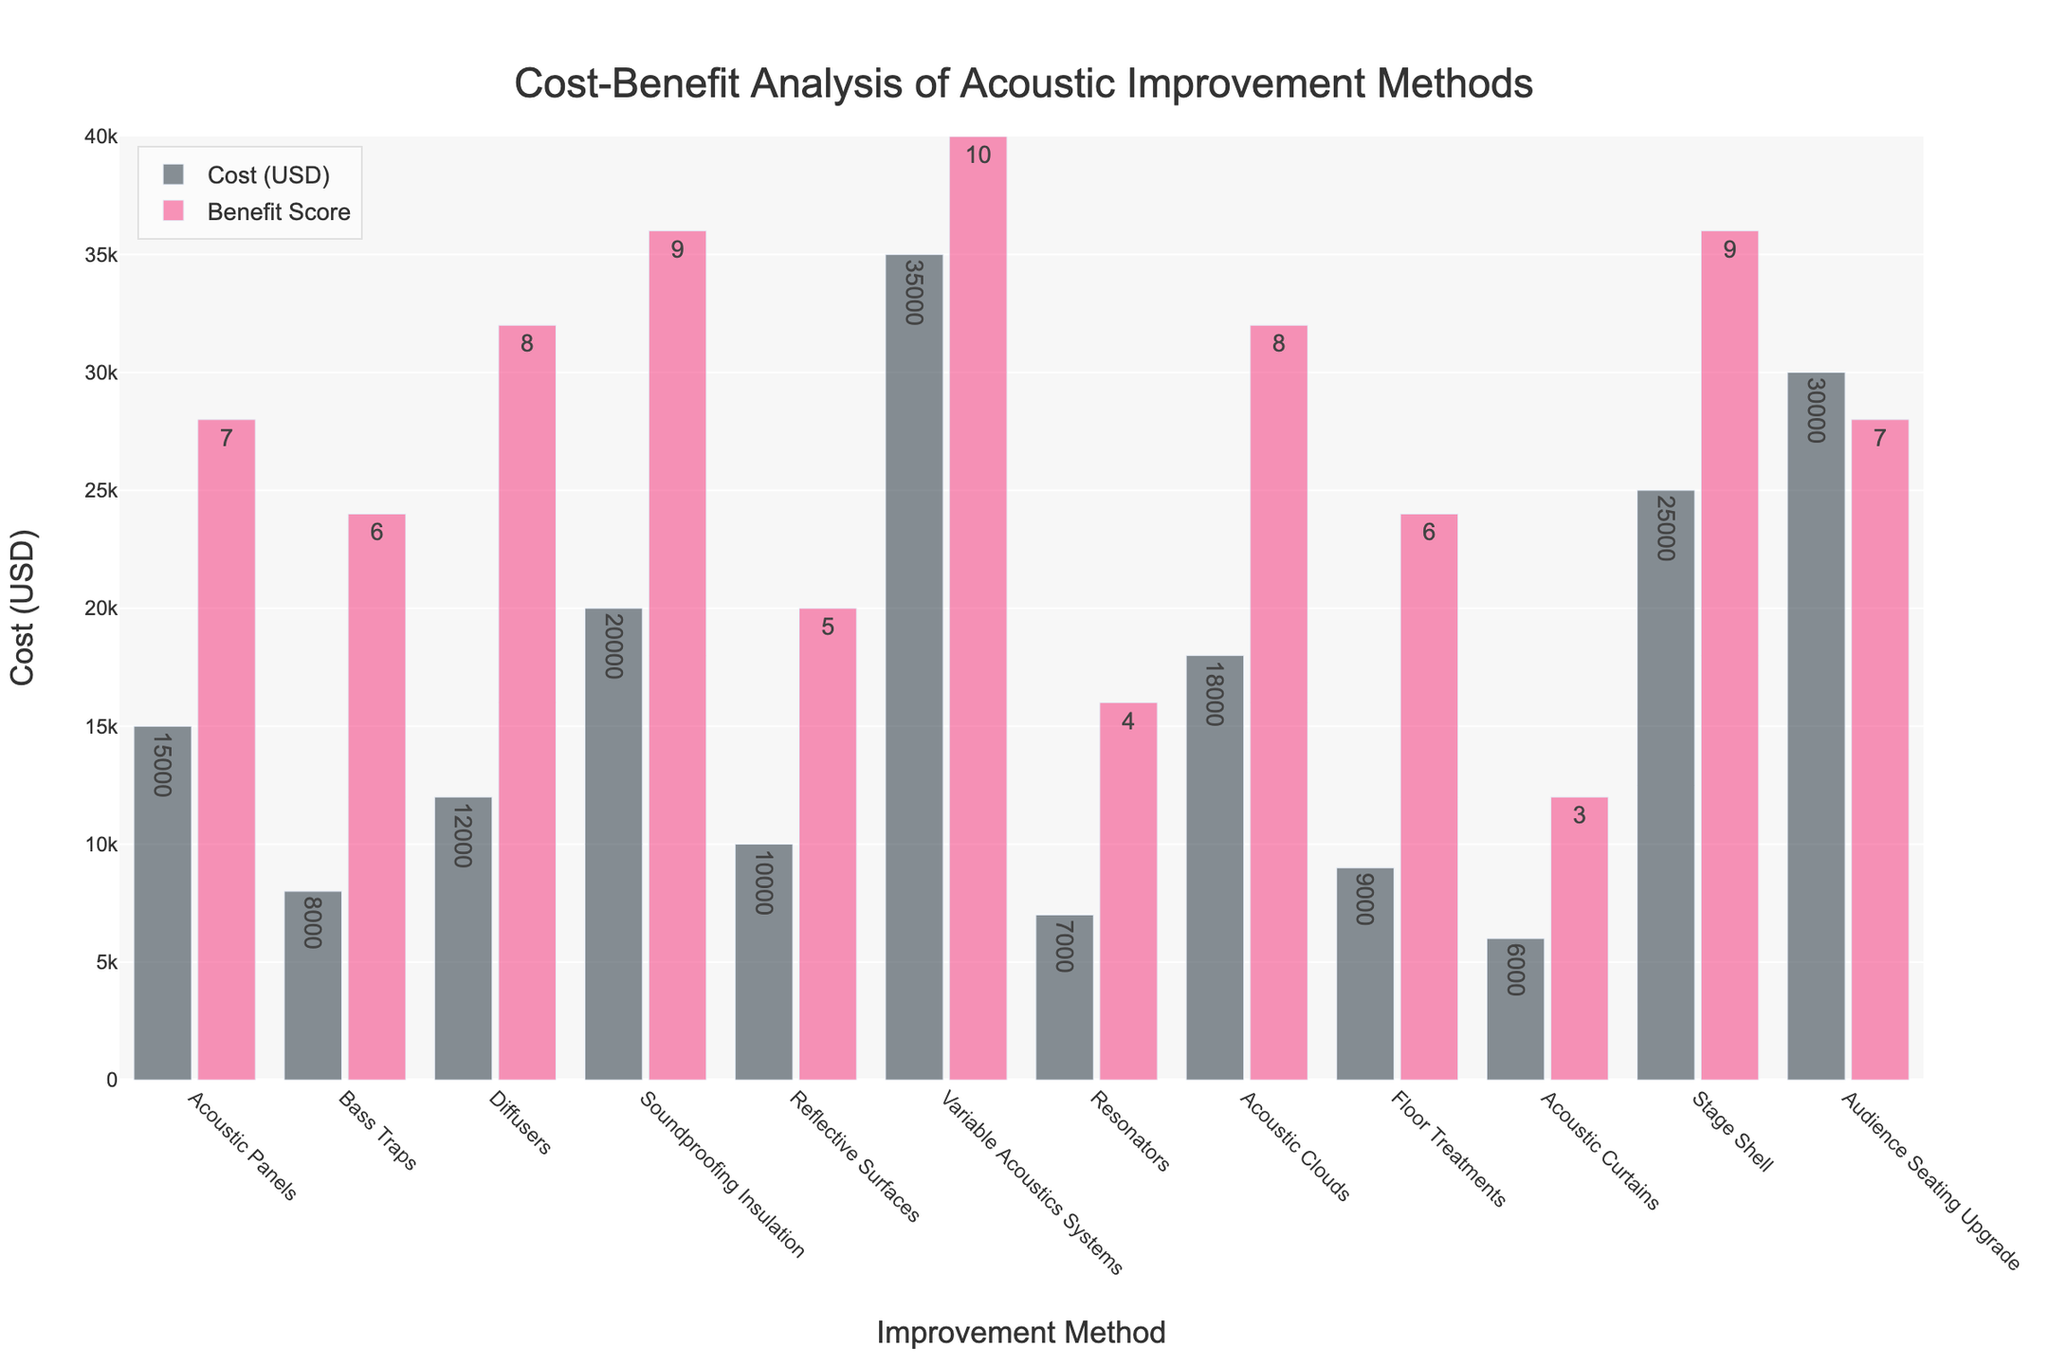Which improvement method has the highest benefit score? By looking at the height of the pink bars in the figure, the highest benefit score is 10, which corresponds to the Variable Acoustics Systems method.
Answer: Variable Acoustics Systems Which method has the lowest cost? By comparing the height of the brown bars in the figure, the lowest cost is 6000 USD, which corresponds to the Acoustic Curtains method.
Answer: Acoustic Curtains What is the total cost for Acoustic Panels, Bass Traps, and Diffusers combined? Add the costs for each method: Acoustic Panels (15000 USD) + Bass Traps (8000 USD) + Diffusers (12000 USD). 15000 + 8000 + 12000 = 35000 USD.
Answer: 35000 USD Which method provides a better cost-benefit ratio: Acoustic Panels or Floor Treatments? Calculate the cost-benefit ratio for both methods by dividing the cost by the benefit score and comparing them. Acoustic Panels: 15000/7 ≈ 2143 USD per benefit point. Floor Treatments: 9000/6 = 1500 USD per benefit point. Floor Treatments has a better ratio.
Answer: Floor Treatments Which method has a benefit score less than 5 and what is its cost? Look at the pink bars with a height corresponding to benefit scores less than 5. Resonators and Acoustic Curtains have benefit scores of 4 and 3, respectively. The costs are 7000 USD and 6000 USD.
Answer: Resonators and Acoustic Curtains, cost: 7000 USD and 6000 USD respectively What is the difference in cost between the most expensive and the least expensive methods? The most expensive method is Variable Acoustics Systems (35000 USD), and the least expensive method is Acoustic Curtains (6000 USD). Subtract the cost of Acoustic Curtains from Variable Acoustics Systems: 35000 - 6000 = 29000 USD.
Answer: 29000 USD Which improvement methods have a benefit score of 8? Identify the pink bars with a height corresponding to a benefit score of 8. The methods are Diffusers and Acoustic Clouds.
Answer: Diffusers and Acoustic Clouds What is the average cost of all improvement methods? Sum all the costs and divide by the number of methods. Total cost is 15000 + 8000 + 12000 + 20000 + 10000 + 35000 + 7000 + 18000 + 9000 + 6000 + 25000 + 30000 = 211000 USD. There are 12 methods, so the average cost is 211000/12 ≈ 17583 USD.
Answer: 17583 USD Which method has the highest cost among those with a benefit score of 9? Look at the pink bars with a height corresponding to a benefit score of 9. The methods are Soundproofing Insulation and Stage Shell. Compare their costs: Soundproofing Insulation (20000 USD) and Stage Shell (25000 USD). The highest cost is for Stage Shell.
Answer: Stage Shell How many methods have a cost above 20000 USD, and what are they? Identify the brown bars with a height greater than 20000 USD. The methods are Variable Acoustics Systems, Stage Shell, and Audience Seating Upgrade. There are 3 methods.
Answer: 3 methods: Variable Acoustics Systems, Stage Shell, Audience Seating Upgrade 